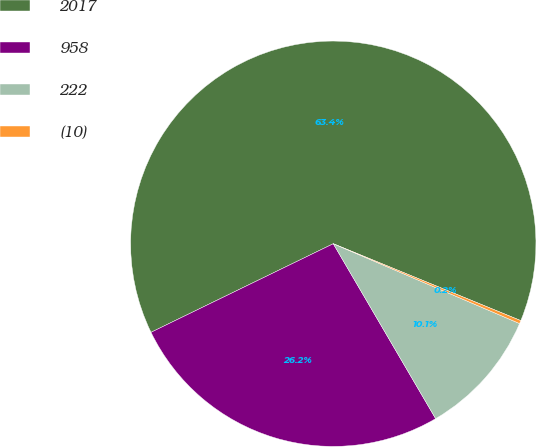Convert chart to OTSL. <chart><loc_0><loc_0><loc_500><loc_500><pie_chart><fcel>2017<fcel>958<fcel>222<fcel>(10)<nl><fcel>63.4%<fcel>26.23%<fcel>10.13%<fcel>0.25%<nl></chart> 